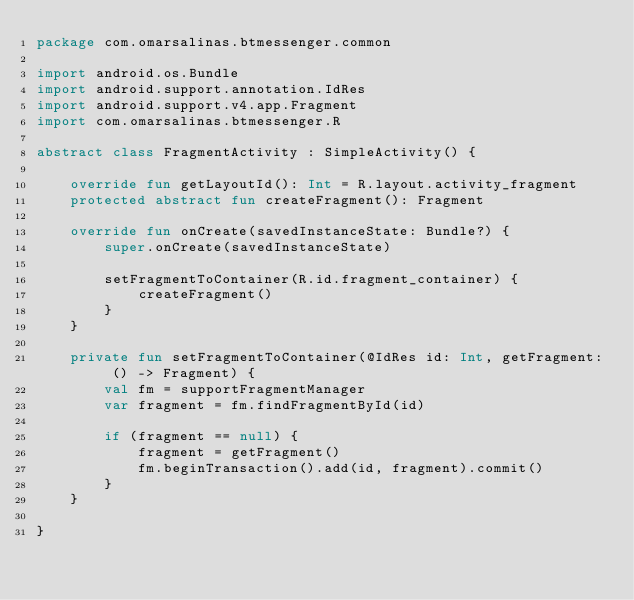Convert code to text. <code><loc_0><loc_0><loc_500><loc_500><_Kotlin_>package com.omarsalinas.btmessenger.common

import android.os.Bundle
import android.support.annotation.IdRes
import android.support.v4.app.Fragment
import com.omarsalinas.btmessenger.R

abstract class FragmentActivity : SimpleActivity() {

    override fun getLayoutId(): Int = R.layout.activity_fragment
    protected abstract fun createFragment(): Fragment

    override fun onCreate(savedInstanceState: Bundle?) {
        super.onCreate(savedInstanceState)

        setFragmentToContainer(R.id.fragment_container) {
            createFragment()
        }
    }

    private fun setFragmentToContainer(@IdRes id: Int, getFragment: () -> Fragment) {
        val fm = supportFragmentManager
        var fragment = fm.findFragmentById(id)

        if (fragment == null) {
            fragment = getFragment()
            fm.beginTransaction().add(id, fragment).commit()
        }
    }

}</code> 